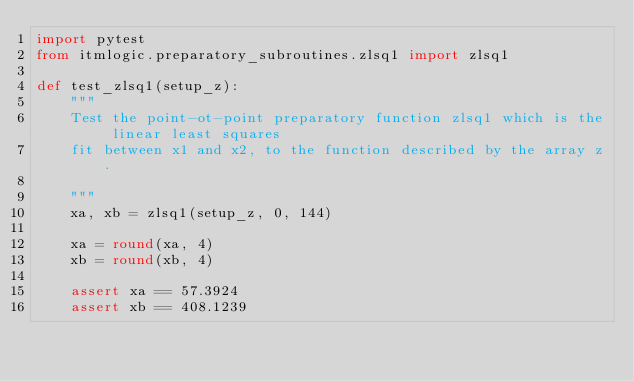<code> <loc_0><loc_0><loc_500><loc_500><_Python_>import pytest
from itmlogic.preparatory_subroutines.zlsq1 import zlsq1

def test_zlsq1(setup_z):
    """
    Test the point-ot-point preparatory function zlsq1 which is the linear least squares
    fit between x1 and x2, to the function described by the array z.

    """
    xa, xb = zlsq1(setup_z, 0, 144)

    xa = round(xa, 4)
    xb = round(xb, 4)

    assert xa == 57.3924
    assert xb == 408.1239
</code> 